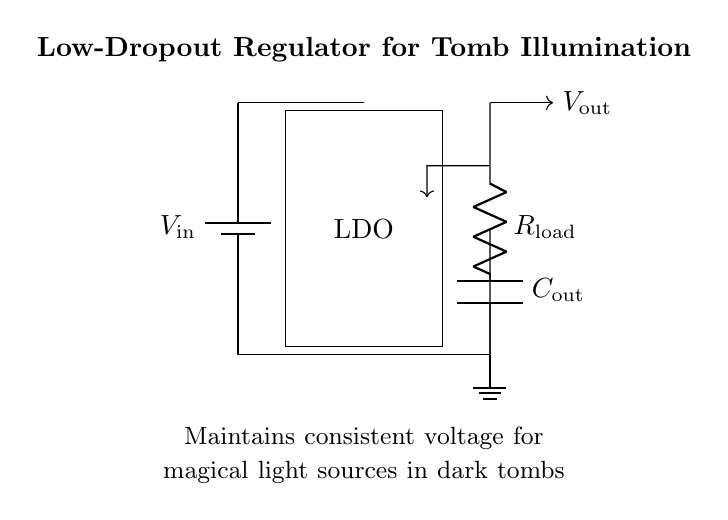What is the type of regulator depicted in the circuit? The circuit diagram shows a low-dropout regulator, which is designed to maintain a steady output voltage while allowing a small difference between input and output voltage.
Answer: low-dropout regulator What is the purpose of the output capacitor in this circuit? The output capacitor helps stabilize the output voltage by smoothing voltage fluctuations and reducing noise, ensuring consistent illumination.
Answer: stabilize output voltage What component represents the load in this circuit? The load in the circuit is represented by the resistor labeled as the load resistor, which simulates the illumination device used in the tomb.
Answer: load resistor What is the importance of the feedback loop in the regulator circuit? The feedback loop adjusts the regulator's output to ensure the voltage remains consistent despite variations in input voltage or load current, which is crucial for stable illumination.
Answer: ensures consistent voltage What is the typical role of the voltage source labeled as V_in in the circuit? The voltage source labeled V_in provides the necessary input voltage required for the low-dropout regulator to function and produce a regulated output.
Answer: input voltage How does the LDO maintain consistent illumination despite changes in load? The LDO automatically adjusts its internal resistance to compensate for changes in load current, thus maintaining a steady output voltage for consistent illumination.
Answer: adjusts internal resistance What does the ground symbol signify in this circuit? The ground symbol indicates a common reference point in the circuit, providing a return path for current and establishing a zero-voltage reference for all other voltages in the circuit.
Answer: common reference point 